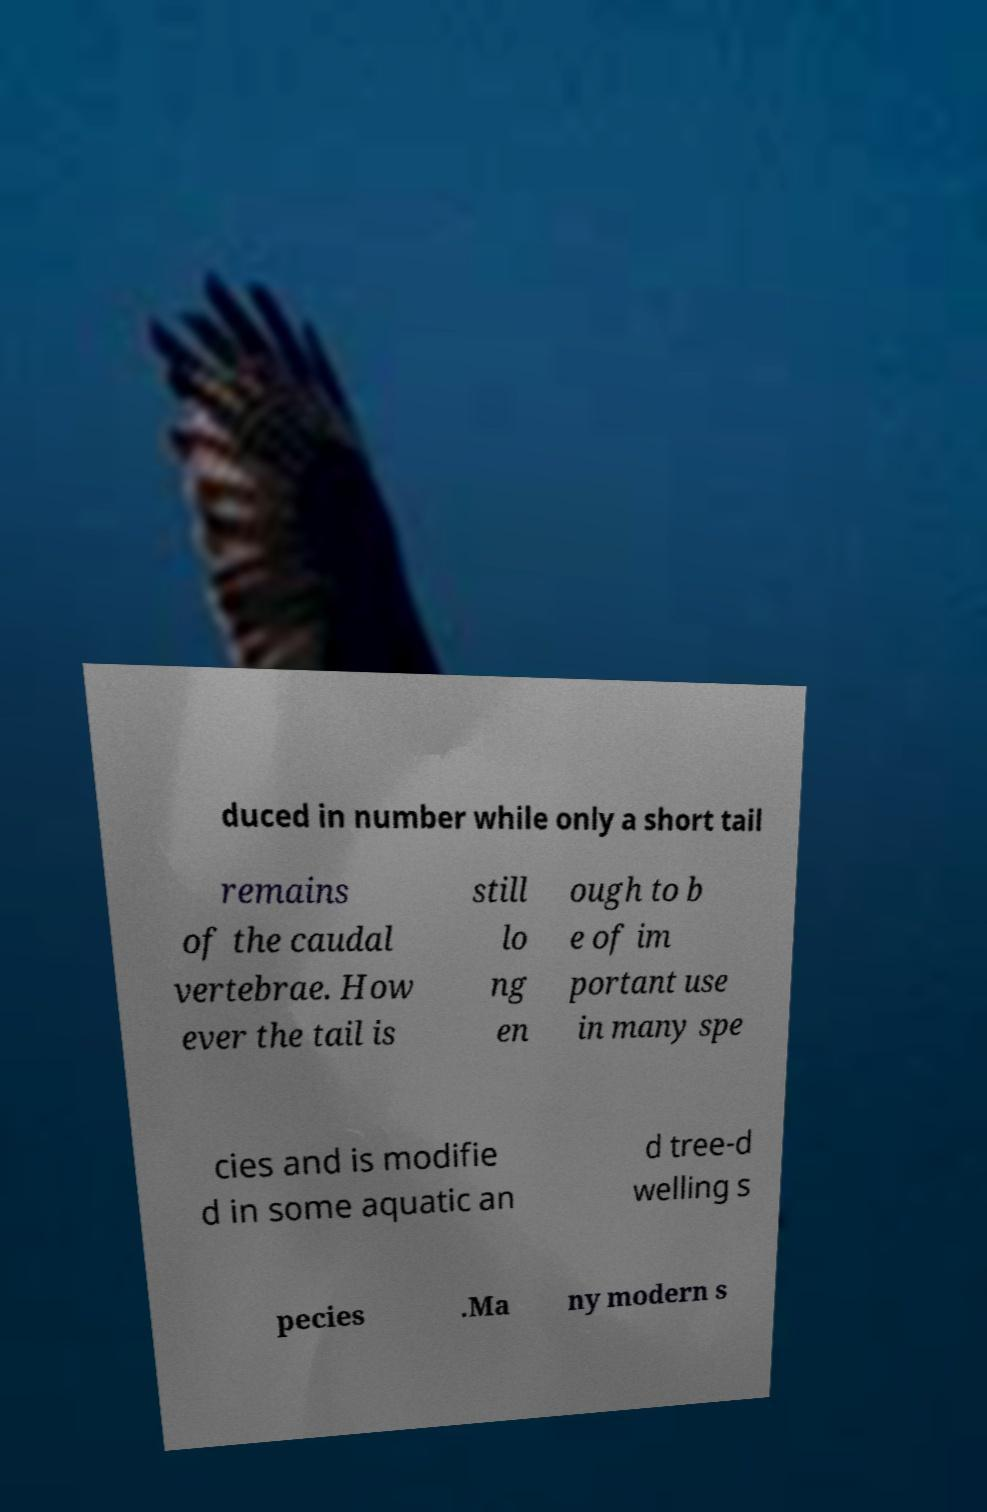Can you read and provide the text displayed in the image?This photo seems to have some interesting text. Can you extract and type it out for me? duced in number while only a short tail remains of the caudal vertebrae. How ever the tail is still lo ng en ough to b e of im portant use in many spe cies and is modifie d in some aquatic an d tree-d welling s pecies .Ma ny modern s 